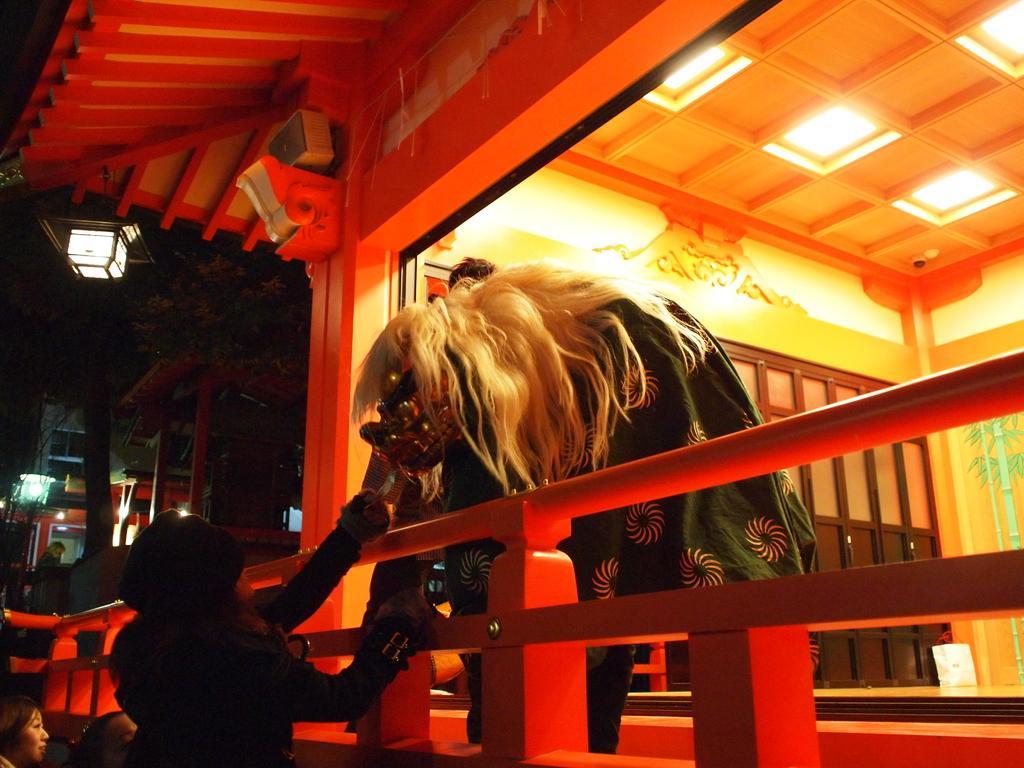Describe this image in one or two sentences. In this image we can see a house. There is a railing. There is a person wearing a mask. There is a lady at the bottom of the image wearing a jacket. In the background of the image there are trees, houses, light pole. 